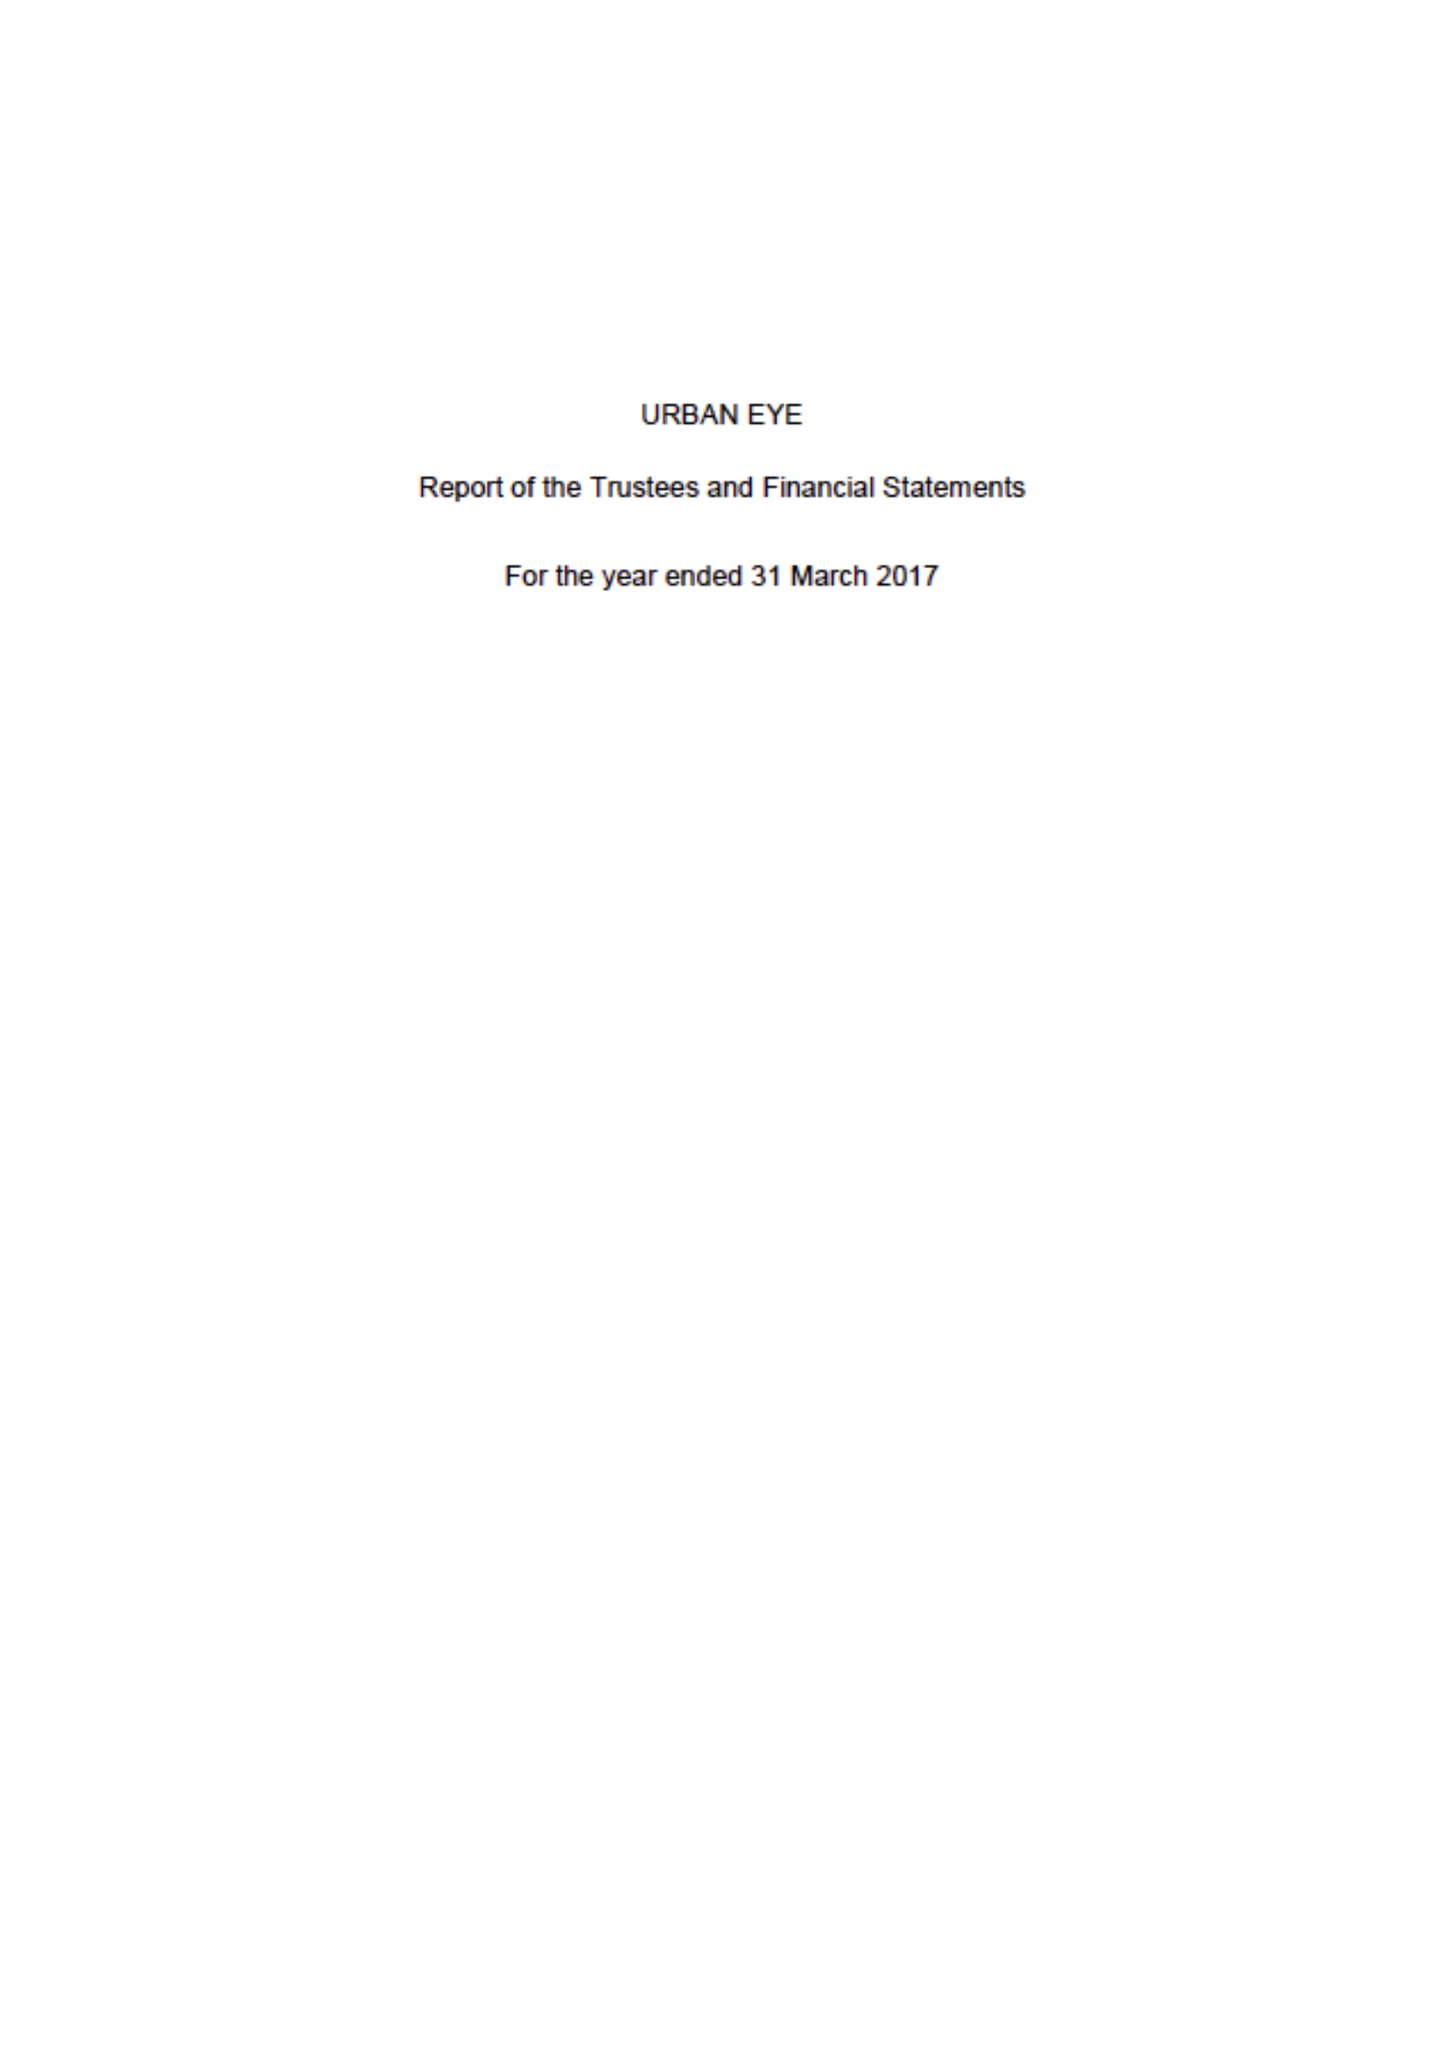What is the value for the report_date?
Answer the question using a single word or phrase. 2017-03-31 